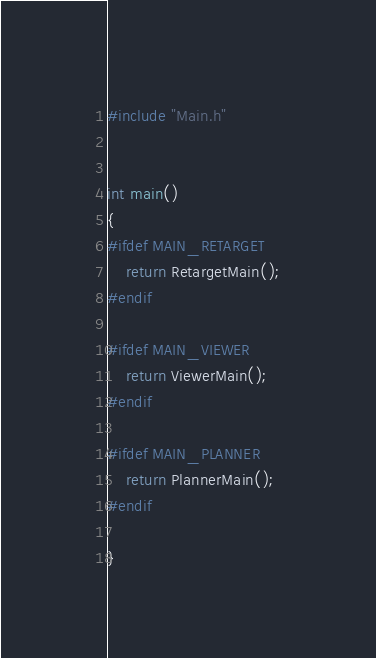Convert code to text. <code><loc_0><loc_0><loc_500><loc_500><_C++_>#include "Main.h"


int main()
{
#ifdef MAIN_RETARGET
	return RetargetMain();
#endif

#ifdef MAIN_VIEWER
	return ViewerMain();
#endif

#ifdef MAIN_PLANNER
	return PlannerMain();
#endif

}</code> 